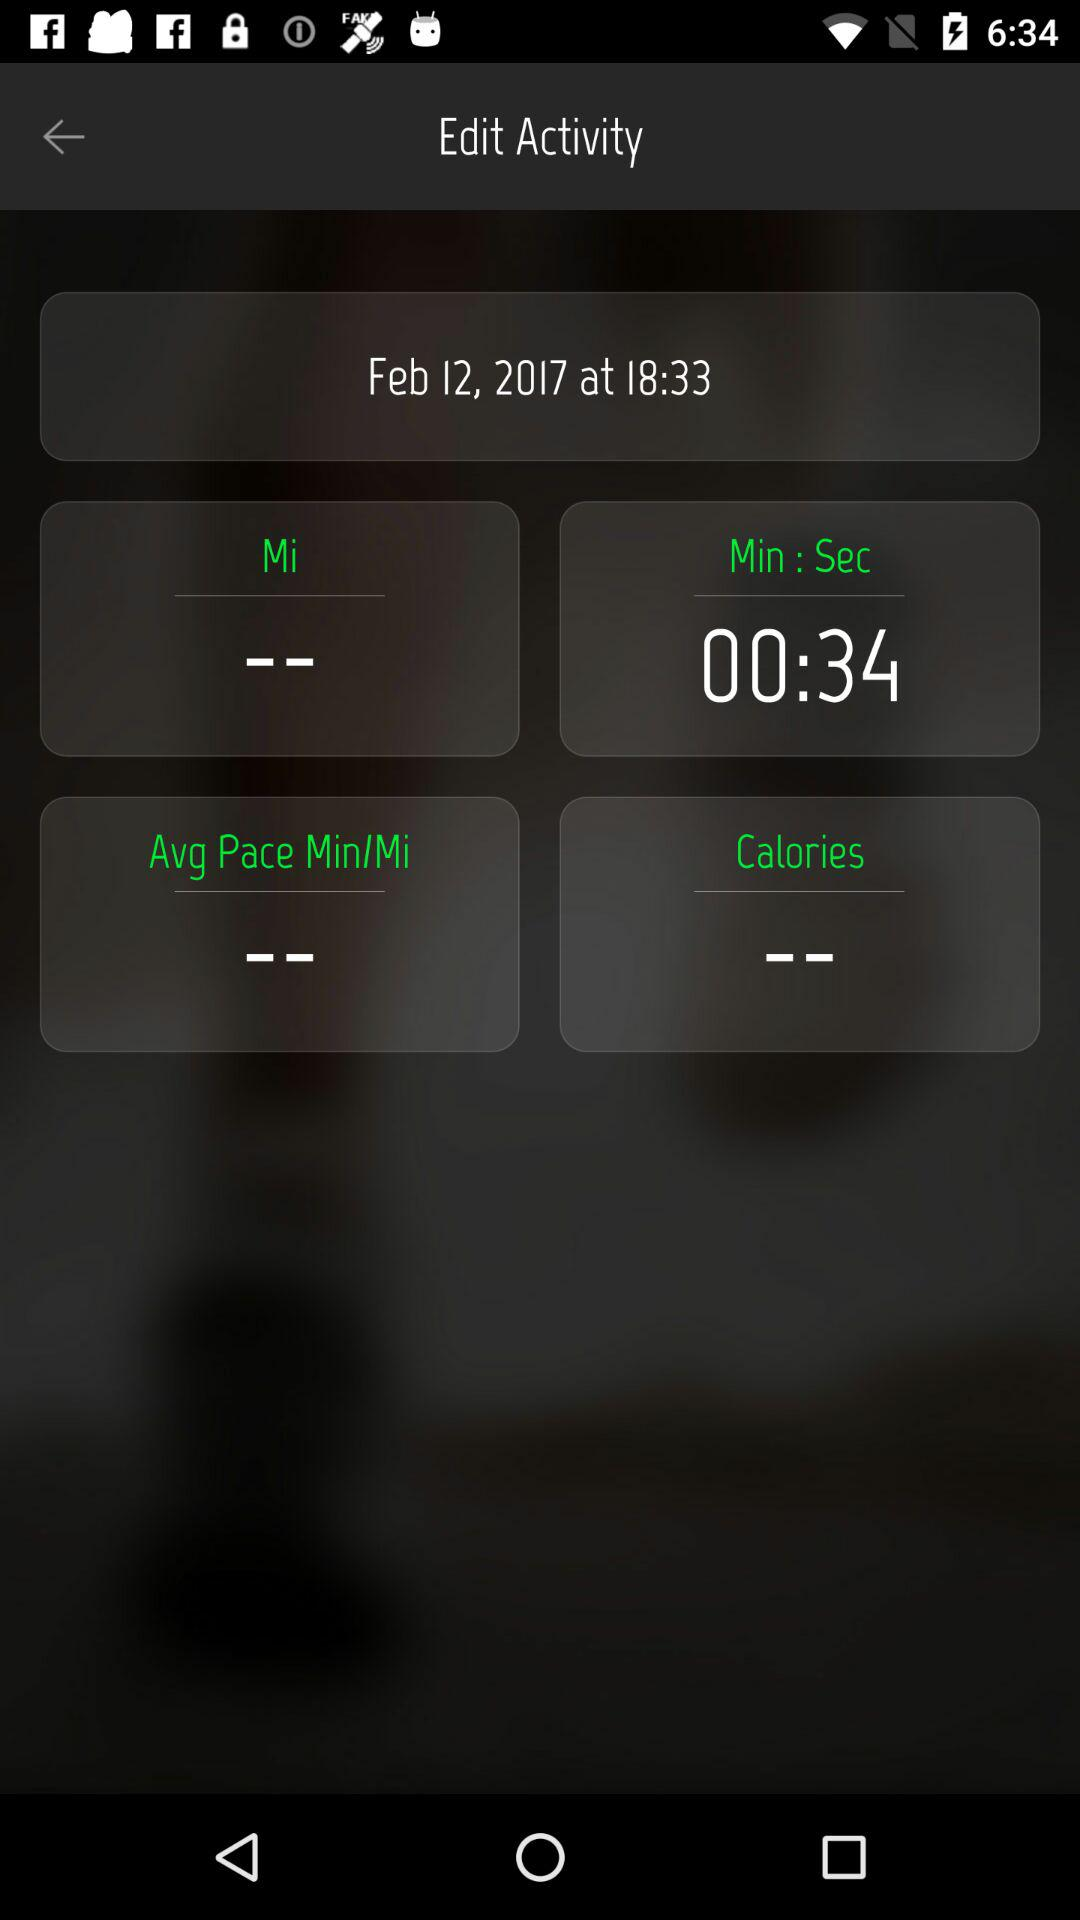What is the given date? The given date is February 12, 2017. 